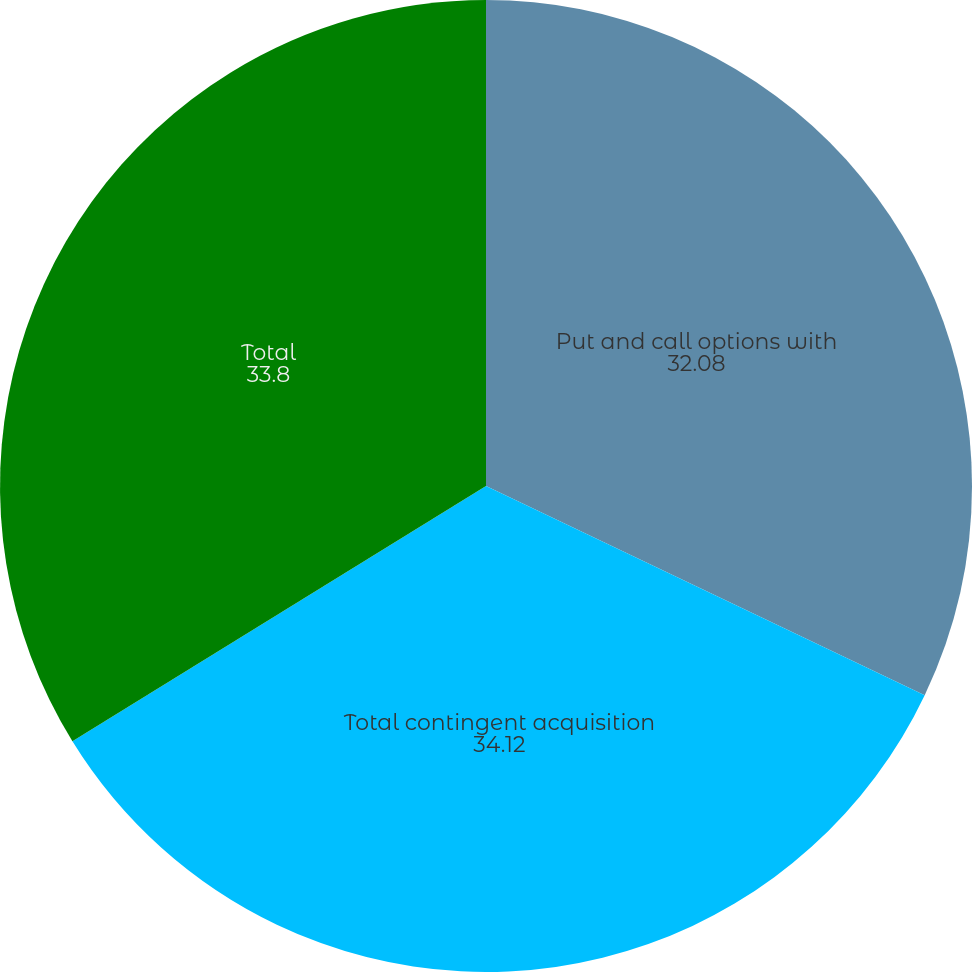Convert chart to OTSL. <chart><loc_0><loc_0><loc_500><loc_500><pie_chart><fcel>Put and call options with<fcel>Total contingent acquisition<fcel>Total<nl><fcel>32.08%<fcel>34.12%<fcel>33.8%<nl></chart> 